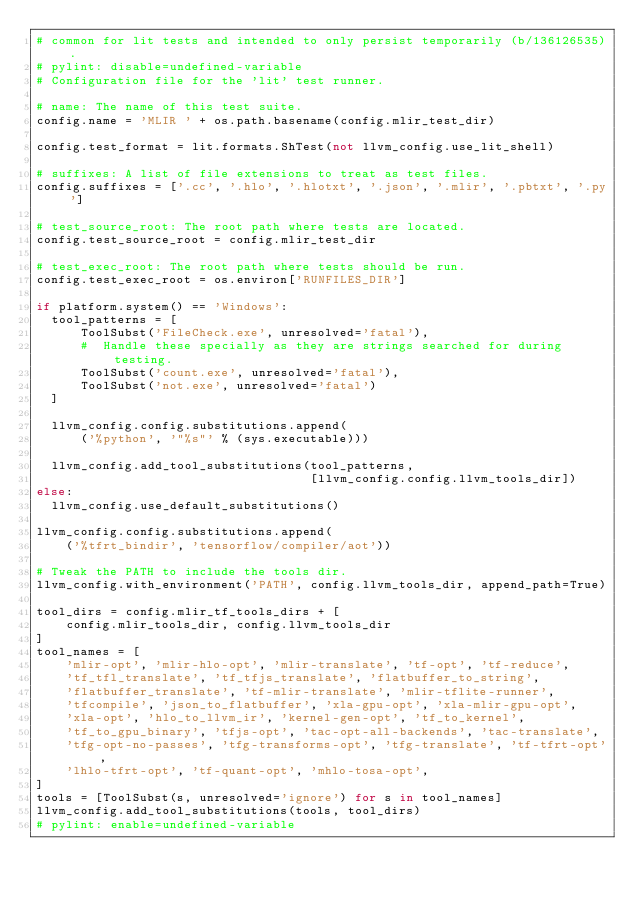<code> <loc_0><loc_0><loc_500><loc_500><_Python_># common for lit tests and intended to only persist temporarily (b/136126535).
# pylint: disable=undefined-variable
# Configuration file for the 'lit' test runner.

# name: The name of this test suite.
config.name = 'MLIR ' + os.path.basename(config.mlir_test_dir)

config.test_format = lit.formats.ShTest(not llvm_config.use_lit_shell)

# suffixes: A list of file extensions to treat as test files.
config.suffixes = ['.cc', '.hlo', '.hlotxt', '.json', '.mlir', '.pbtxt', '.py']

# test_source_root: The root path where tests are located.
config.test_source_root = config.mlir_test_dir

# test_exec_root: The root path where tests should be run.
config.test_exec_root = os.environ['RUNFILES_DIR']

if platform.system() == 'Windows':
  tool_patterns = [
      ToolSubst('FileCheck.exe', unresolved='fatal'),
      #  Handle these specially as they are strings searched for during testing.
      ToolSubst('count.exe', unresolved='fatal'),
      ToolSubst('not.exe', unresolved='fatal')
  ]

  llvm_config.config.substitutions.append(
      ('%python', '"%s"' % (sys.executable)))

  llvm_config.add_tool_substitutions(tool_patterns,
                                     [llvm_config.config.llvm_tools_dir])
else:
  llvm_config.use_default_substitutions()

llvm_config.config.substitutions.append(
    ('%tfrt_bindir', 'tensorflow/compiler/aot'))

# Tweak the PATH to include the tools dir.
llvm_config.with_environment('PATH', config.llvm_tools_dir, append_path=True)

tool_dirs = config.mlir_tf_tools_dirs + [
    config.mlir_tools_dir, config.llvm_tools_dir
]
tool_names = [
    'mlir-opt', 'mlir-hlo-opt', 'mlir-translate', 'tf-opt', 'tf-reduce',
    'tf_tfl_translate', 'tf_tfjs_translate', 'flatbuffer_to_string',
    'flatbuffer_translate', 'tf-mlir-translate', 'mlir-tflite-runner',
    'tfcompile', 'json_to_flatbuffer', 'xla-gpu-opt', 'xla-mlir-gpu-opt',
    'xla-opt', 'hlo_to_llvm_ir', 'kernel-gen-opt', 'tf_to_kernel',
    'tf_to_gpu_binary', 'tfjs-opt', 'tac-opt-all-backends', 'tac-translate',
    'tfg-opt-no-passes', 'tfg-transforms-opt', 'tfg-translate', 'tf-tfrt-opt',
    'lhlo-tfrt-opt', 'tf-quant-opt', 'mhlo-tosa-opt',
]
tools = [ToolSubst(s, unresolved='ignore') for s in tool_names]
llvm_config.add_tool_substitutions(tools, tool_dirs)
# pylint: enable=undefined-variable
</code> 